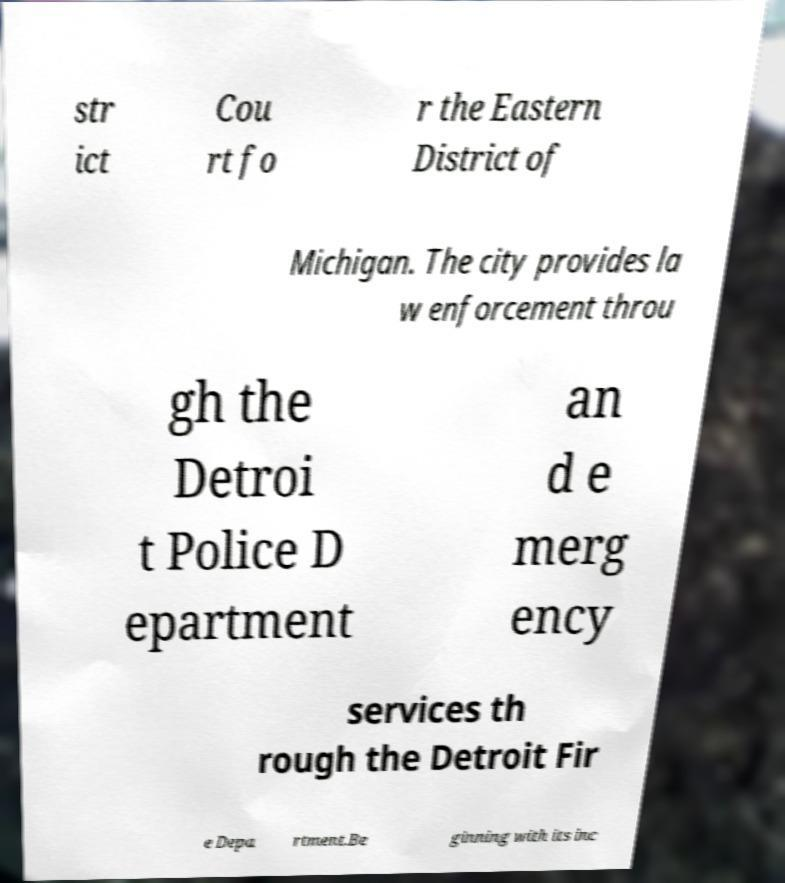Could you assist in decoding the text presented in this image and type it out clearly? str ict Cou rt fo r the Eastern District of Michigan. The city provides la w enforcement throu gh the Detroi t Police D epartment an d e merg ency services th rough the Detroit Fir e Depa rtment.Be ginning with its inc 